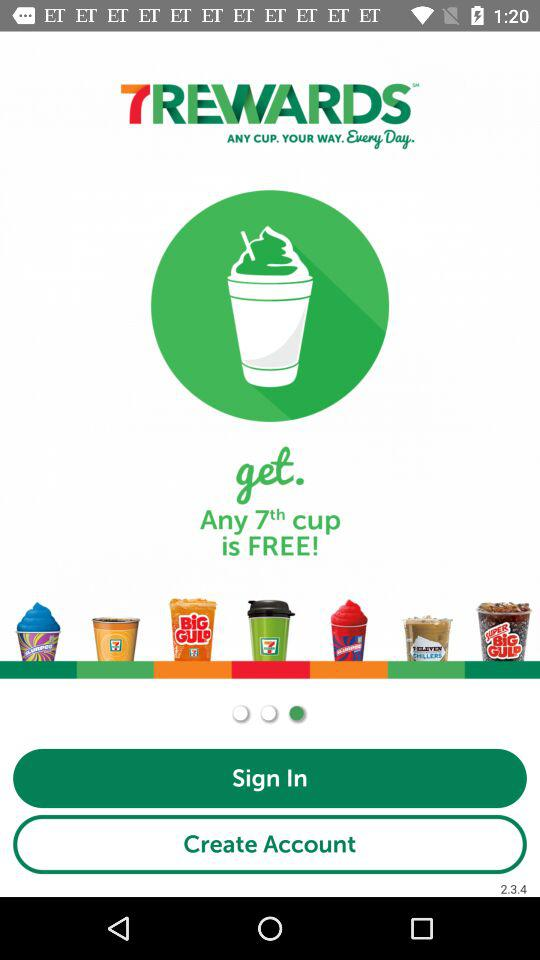What is the name of the application? The name of the application is 7REWARDS. 